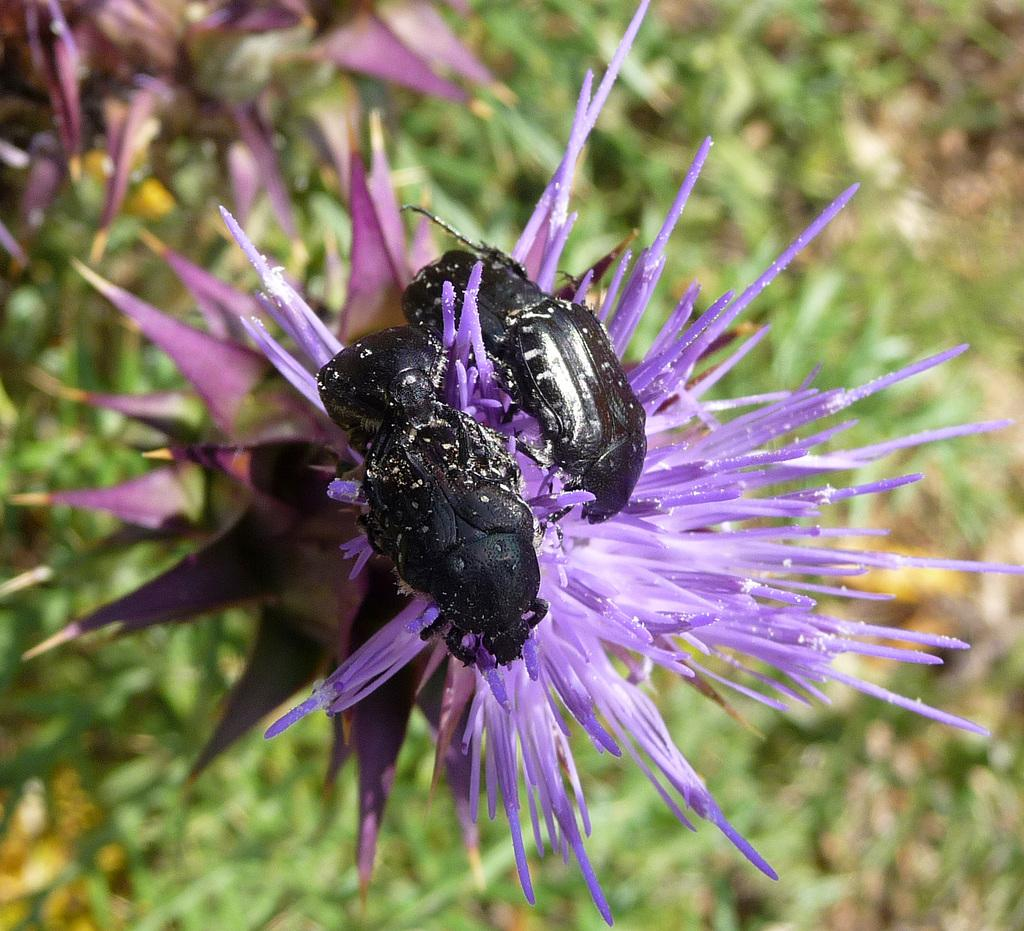What creatures are present in the image? There are two bugs in the image. What are the bugs standing on? The bugs are standing on a purple flower. What type of vegetation is visible in the image? There are many plants on the ground in the image. What type of pen is visible in the image? There is no pen present in the image. 